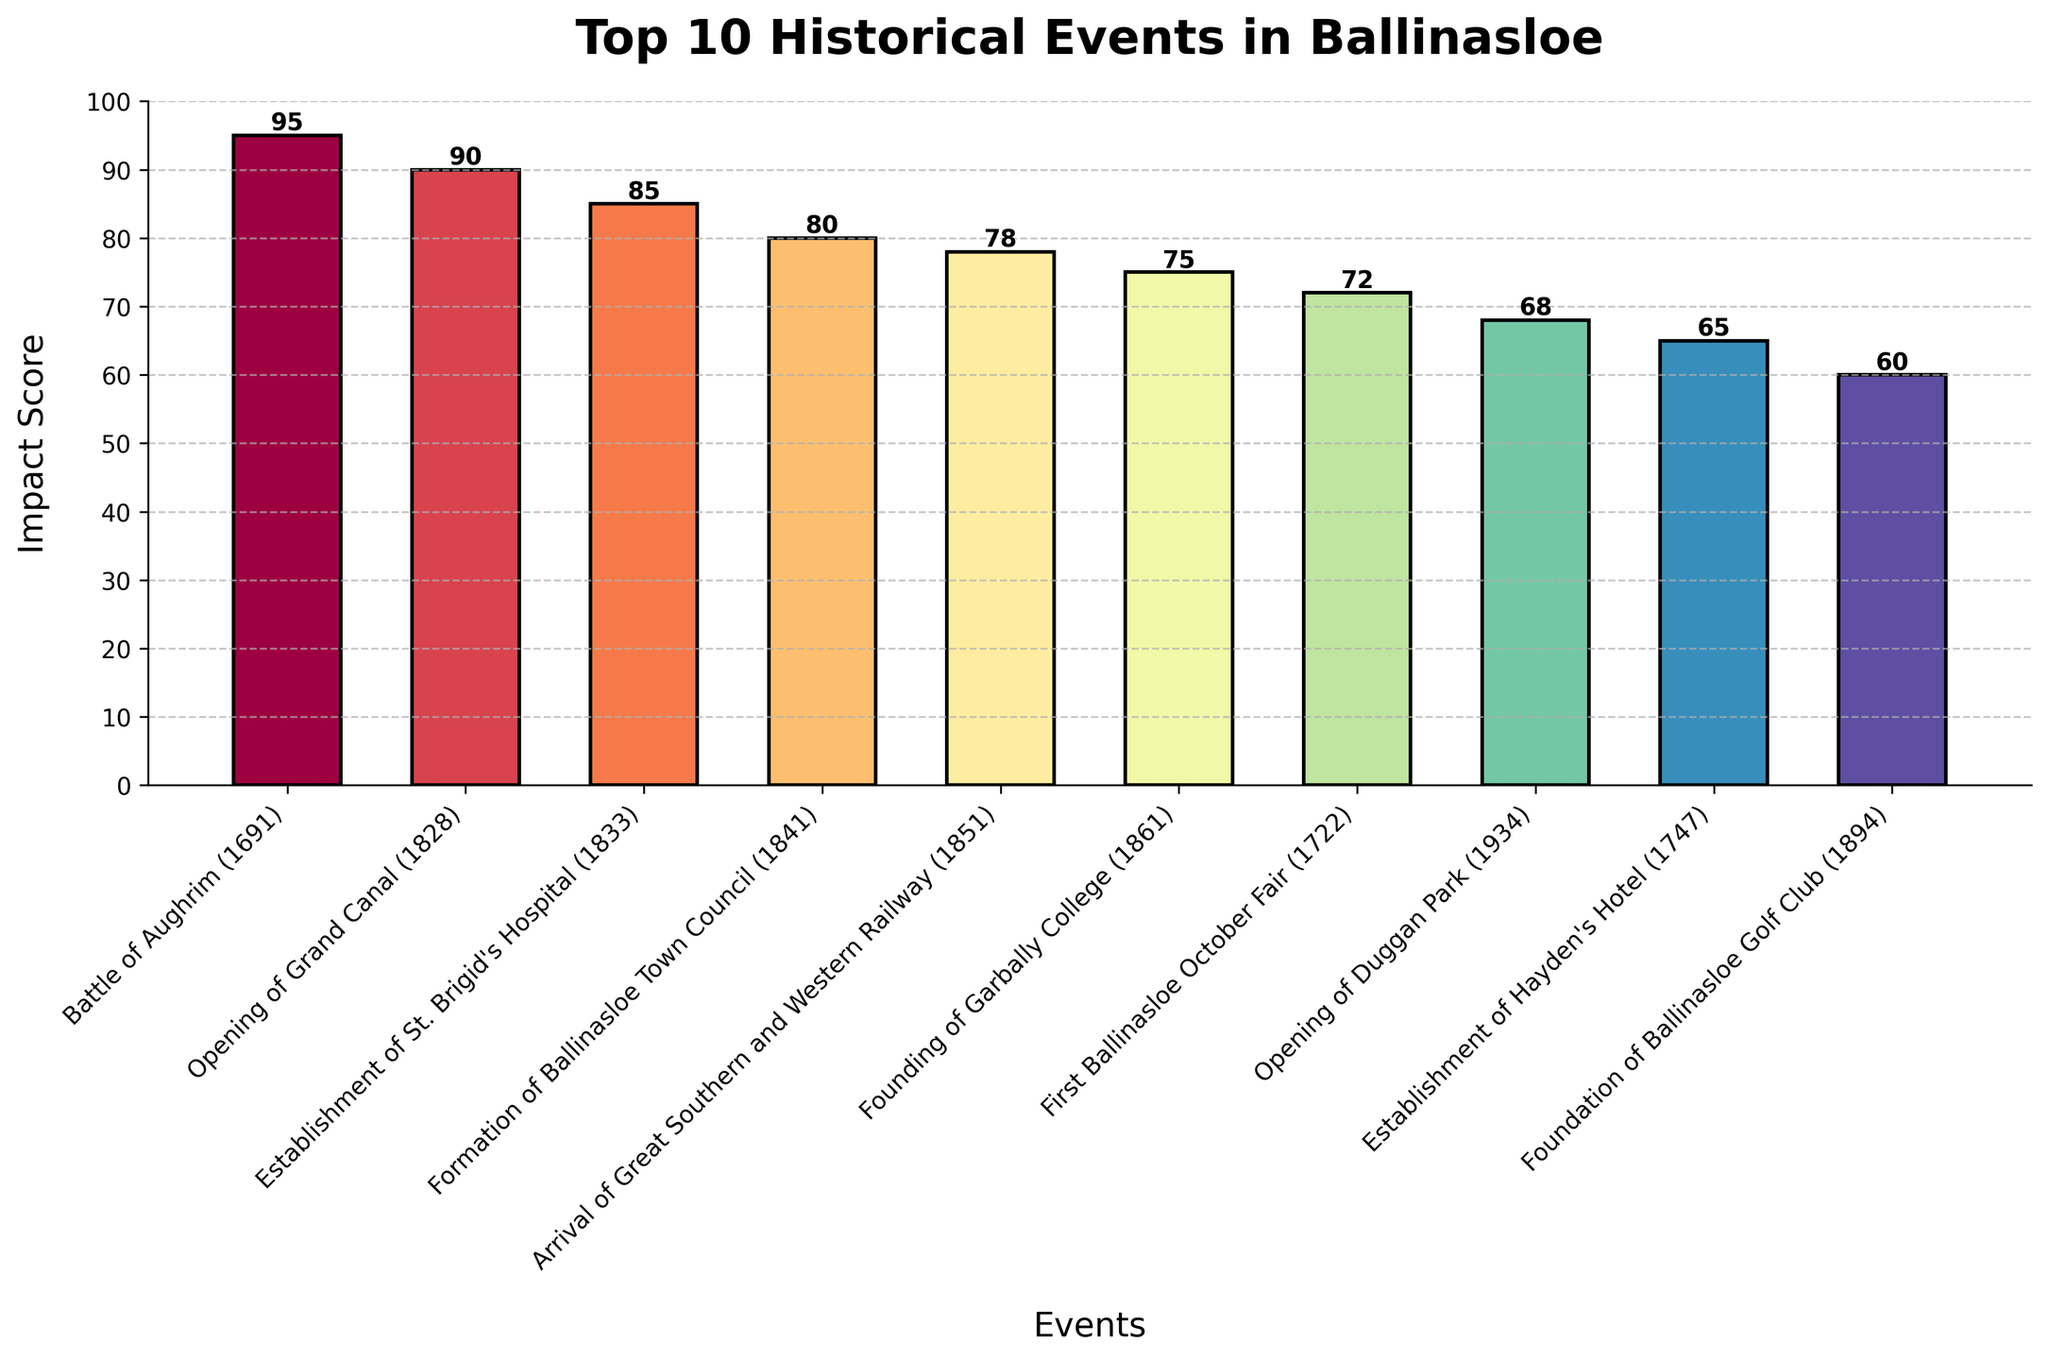Which event has the highest impact score? The event with the highest impact score has the tallest bar in the plot. By comparing the heights of all the bars, the "Battle of Aughrim (1691)" event has the tallest bar, corresponding to an impact score of 95.
Answer: Battle of Aughrim (1691) How does the impact score of the Founding of Garbally College compare to the Arrival of Great Southern and Western Railway? The impact score of the Founding of Garbally College is 75, while the Arrival of Great Southern and Western Railway has a score of 78. Therefore, the Arrival of Great Southern and Western Railway has a slightly higher impact score.
Answer: The Arrival of Great Southern and Western Railway has a higher impact score (78 vs 75) What is the average impact score of the events ranked 6th to 10th? The events ranked 6th to 10th are the First Ballinasloe October Fair (72), Opening of Duggan Park (68), Establishment of Hayden's Hotel (65), and Foundation of Ballinasloe Golf Club (60). The total of these scores is 335, and there are 5 events, so the average is 67.
Answer: 67 What is the total impact score of all events combined? To find the total impact score, add the impact scores of all events: 95 + 90 + 85 + 80 + 78 + 75 + 72 + 68 + 65 + 60, which equals 768.
Answer: 768 Which two events have the closest impact scores, and what are their scores? The closest impact scores are between the Arrival of Great Southern and Western Railway (78) and the Founding of Garbally College (75). The difference between their scores is 3.
Answer: Arrival of Great Southern and Western Railway (78), Founding of Garbally College (75) What is the impact score difference between the event with the highest score and the event with the lowest score? The event with the highest impact score is the Battle of Aughrim (1691) with a score of 95, and the event with the lowest impact score is Foundation of Ballinasloe Golf Club with a score of 60. The difference is 95 - 60, which is 35.
Answer: 35 Is the Establishment of St. Brigid's Hospital impact score higher or lower than the average impact score of all events? The impact score of the Establishment of St. Brigid's Hospital is 85. The average impact score of all events is the total score (768) divided by the number of events (10), which equals 76.8. Since 85 is greater than 76.8, the impact score is higher than average.
Answer: Higher Which events have impact scores that are above 80? The events with impact scores above 80 are Battle of Aughrim (1691) with 95, Opening of Grand Canal (1828) with 90, Establishment of St. Brigid's Hospital (1833) with 85, and Formation of Ballinasloe Town Council (1841) with 80.
Answer: Battle of Aughrim (1691), Opening of Grand Canal (1828), Establishment of St. Brigid's Hospital (1833), Formation of Ballinasloe Town Council (1841) 